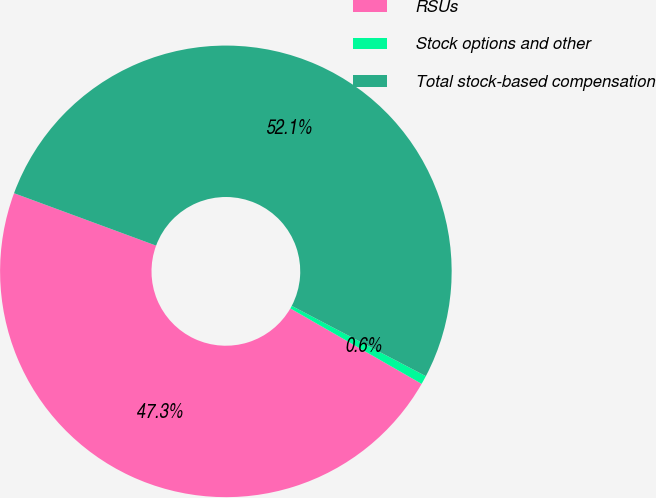Convert chart to OTSL. <chart><loc_0><loc_0><loc_500><loc_500><pie_chart><fcel>RSUs<fcel>Stock options and other<fcel>Total stock-based compensation<nl><fcel>47.32%<fcel>0.62%<fcel>52.05%<nl></chart> 